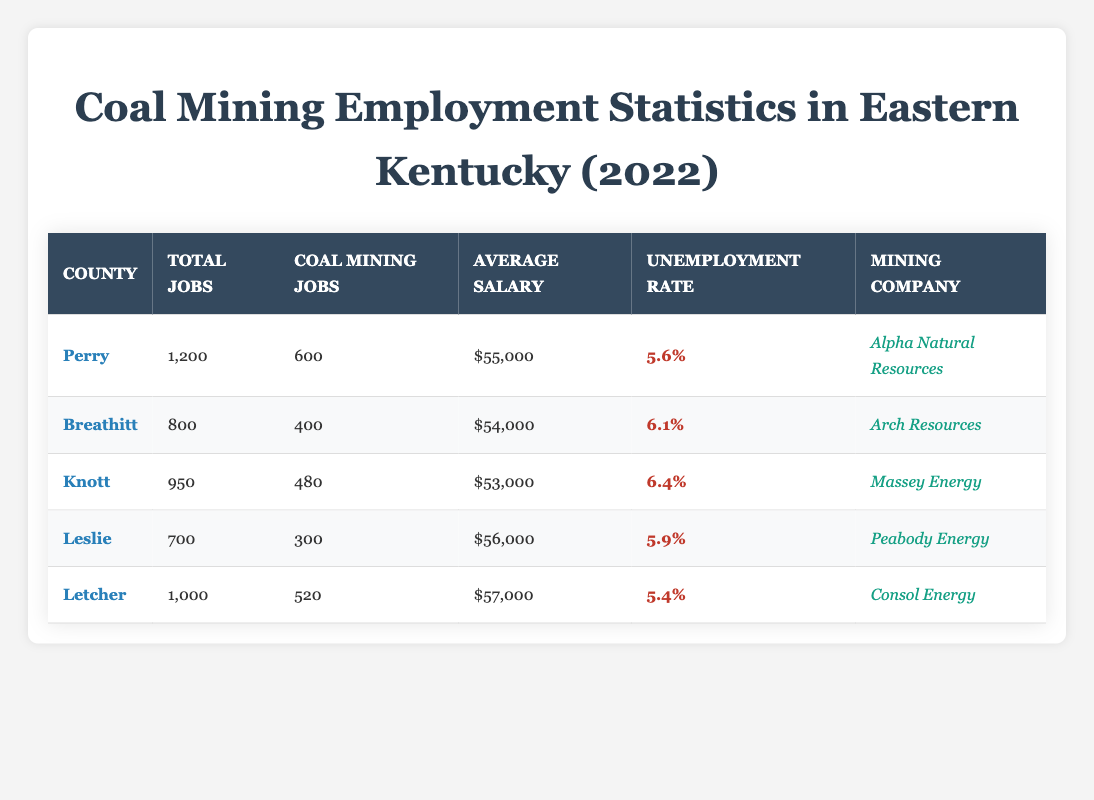What is the average salary for coal mining jobs in Perry County? According to the table, Perry County has an average salary of $55,000 for coal mining jobs.
Answer: $55,000 Which county has the highest unemployment rate? By examining the unemployment rates in the table, Knott County has the highest unemployment rate at 6.4%.
Answer: Knott How many total jobs are there in Leslie County? The table states that Leslie County has a total of 700 jobs listed.
Answer: 700 What is the combined number of coal mining jobs in Breathitt and Knott counties? The table lists 400 coal mining jobs in Breathitt County and 480 in Knott County. Adding these together gives 400 + 480 = 880.
Answer: 880 Is the average salary for coal mining jobs in Letcher County greater than $55,000? The average salary for coal mining jobs in Letcher County is $57,000, which is indeed greater than $55,000.
Answer: Yes Which mining company operates in Breathitt County? The table shows that Arch Resources operates in Breathitt County.
Answer: Arch Resources What is the difference between the total jobs in Perry County and the total jobs in Leslie County? Perry County has 1,200 total jobs while Leslie County has 700. The difference is 1,200 - 700 = 500.
Answer: 500 How many coal mining jobs are there in Letcher County, and how does that compare to Leslie County? Letcher County has 520 coal mining jobs, while Leslie County has 300. The difference is 520 - 300 = 220 more jobs in Letcher.
Answer: 520 (Letcher has 220 more than Leslie) What is the total number of coal mining jobs across all five counties? Adding the coal mining jobs across all counties: 600 (Perry) + 400 (Breathitt) + 480 (Knott) + 300 (Leslie) + 520 (Letcher) gives us a total of 2,300 coal mining jobs.
Answer: 2,300 